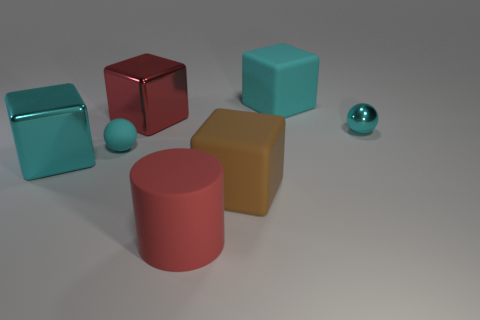What shape is the shiny thing that is the same color as the metal ball?
Keep it short and to the point. Cube. There is a cyan ball that is left of the cube that is behind the red thing that is behind the cylinder; what size is it?
Your response must be concise. Small. What is the red cylinder made of?
Your answer should be compact. Rubber. Do the big brown thing and the big cylinder in front of the big cyan metallic cube have the same material?
Your response must be concise. Yes. Is there any other thing that is the same color as the cylinder?
Make the answer very short. Yes. There is a cyan shiny thing to the left of the large block that is to the right of the brown rubber object; are there any large brown rubber cubes to the left of it?
Your answer should be very brief. No. What color is the cylinder?
Provide a short and direct response. Red. There is a tiny shiny ball; are there any large rubber blocks right of it?
Keep it short and to the point. No. There is a big cyan metallic thing; is its shape the same as the cyan object that is to the right of the big cyan rubber cube?
Give a very brief answer. No. What number of other things are made of the same material as the brown object?
Your answer should be compact. 3. 